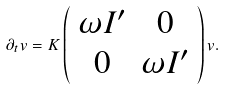Convert formula to latex. <formula><loc_0><loc_0><loc_500><loc_500>\partial _ { t } v = K \left ( \begin{array} { c c } \omega I ^ { \prime } & 0 \\ 0 & \omega I ^ { \prime } \end{array} \right ) v .</formula> 